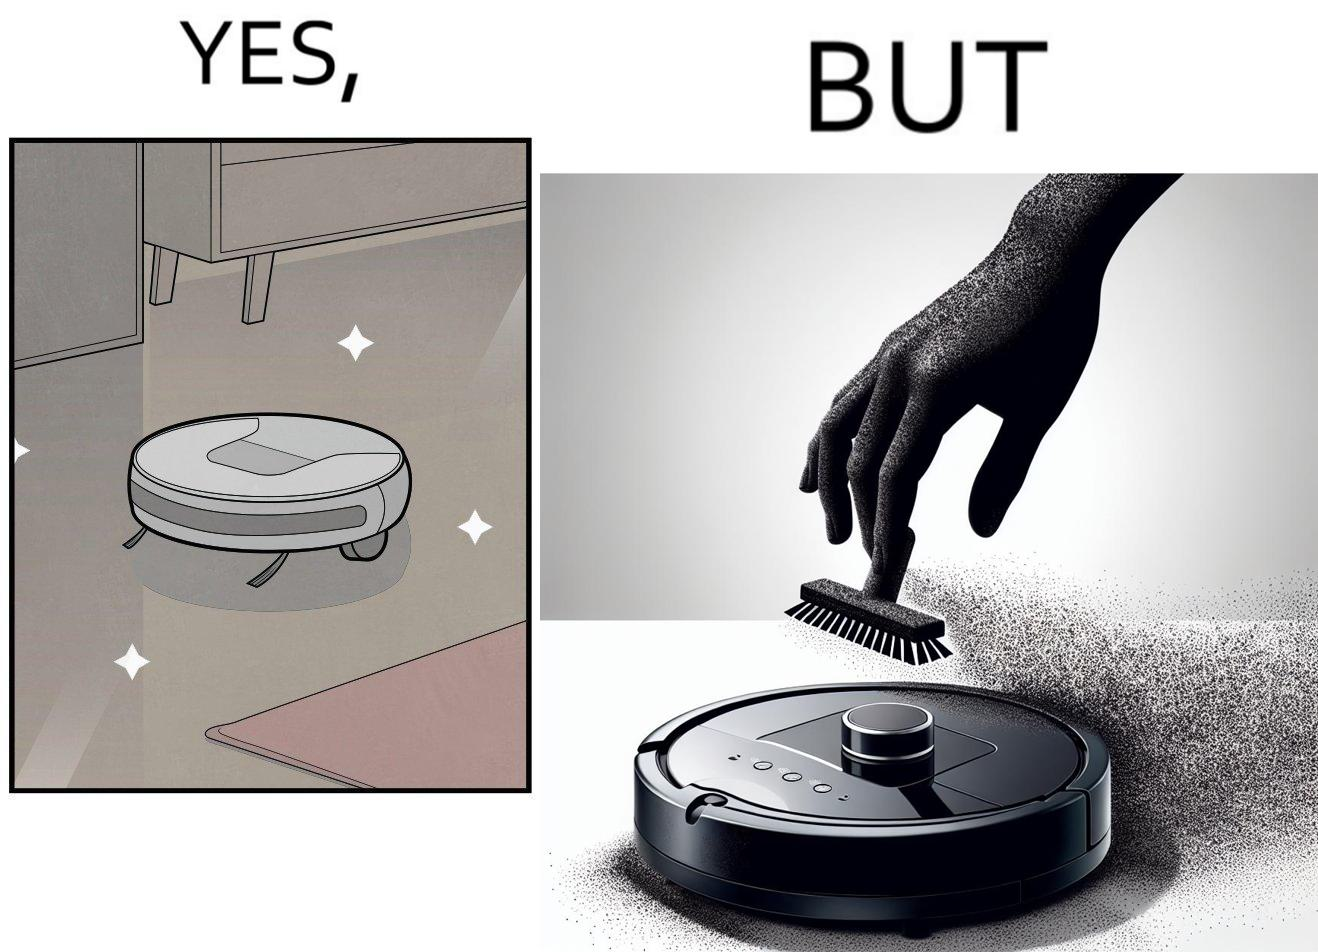Describe the content of this image. This is funny, because the machine while doing its job cleans everything but ends up being dirty itself. 